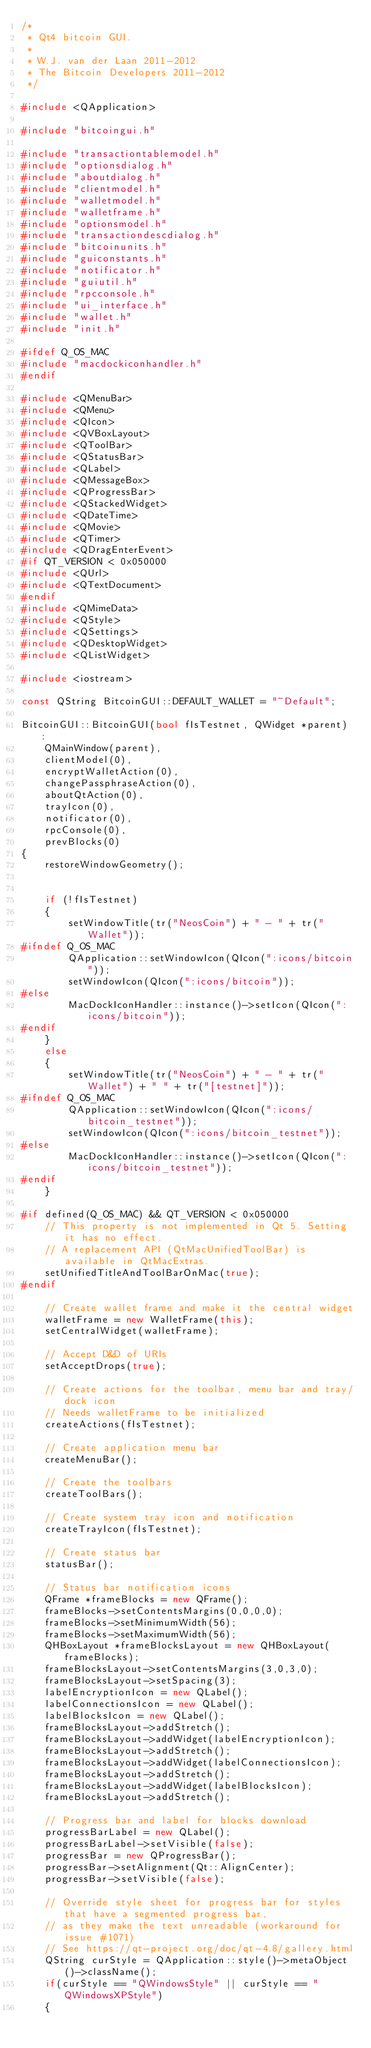<code> <loc_0><loc_0><loc_500><loc_500><_C++_>/*
 * Qt4 bitcoin GUI.
 *
 * W.J. van der Laan 2011-2012
 * The Bitcoin Developers 2011-2012
 */

#include <QApplication>

#include "bitcoingui.h"

#include "transactiontablemodel.h"
#include "optionsdialog.h"
#include "aboutdialog.h"
#include "clientmodel.h"
#include "walletmodel.h"
#include "walletframe.h"
#include "optionsmodel.h"
#include "transactiondescdialog.h"
#include "bitcoinunits.h"
#include "guiconstants.h"
#include "notificator.h"
#include "guiutil.h"
#include "rpcconsole.h"
#include "ui_interface.h"
#include "wallet.h"
#include "init.h"

#ifdef Q_OS_MAC
#include "macdockiconhandler.h"
#endif

#include <QMenuBar>
#include <QMenu>
#include <QIcon>
#include <QVBoxLayout>
#include <QToolBar>
#include <QStatusBar>
#include <QLabel>
#include <QMessageBox>
#include <QProgressBar>
#include <QStackedWidget>
#include <QDateTime>
#include <QMovie>
#include <QTimer>
#include <QDragEnterEvent>
#if QT_VERSION < 0x050000
#include <QUrl>
#include <QTextDocument>
#endif
#include <QMimeData>
#include <QStyle>
#include <QSettings>
#include <QDesktopWidget>
#include <QListWidget>

#include <iostream>

const QString BitcoinGUI::DEFAULT_WALLET = "~Default";

BitcoinGUI::BitcoinGUI(bool fIsTestnet, QWidget *parent) :
    QMainWindow(parent),
    clientModel(0),
    encryptWalletAction(0),
    changePassphraseAction(0),
    aboutQtAction(0),
    trayIcon(0),
    notificator(0),
    rpcConsole(0),
    prevBlocks(0)
{
    restoreWindowGeometry();


    if (!fIsTestnet)
    {
        setWindowTitle(tr("NeosCoin") + " - " + tr("Wallet"));
#ifndef Q_OS_MAC
        QApplication::setWindowIcon(QIcon(":icons/bitcoin"));
        setWindowIcon(QIcon(":icons/bitcoin"));
#else
        MacDockIconHandler::instance()->setIcon(QIcon(":icons/bitcoin"));
#endif
    }
    else
    {
        setWindowTitle(tr("NeosCoin") + " - " + tr("Wallet") + " " + tr("[testnet]"));
#ifndef Q_OS_MAC
        QApplication::setWindowIcon(QIcon(":icons/bitcoin_testnet"));
        setWindowIcon(QIcon(":icons/bitcoin_testnet"));
#else
        MacDockIconHandler::instance()->setIcon(QIcon(":icons/bitcoin_testnet"));
#endif
    }

#if defined(Q_OS_MAC) && QT_VERSION < 0x050000
    // This property is not implemented in Qt 5. Setting it has no effect.
    // A replacement API (QtMacUnifiedToolBar) is available in QtMacExtras.
    setUnifiedTitleAndToolBarOnMac(true);
#endif

    // Create wallet frame and make it the central widget
    walletFrame = new WalletFrame(this);
    setCentralWidget(walletFrame);

    // Accept D&D of URIs
    setAcceptDrops(true);

    // Create actions for the toolbar, menu bar and tray/dock icon
    // Needs walletFrame to be initialized
    createActions(fIsTestnet);

    // Create application menu bar
    createMenuBar();

    // Create the toolbars
    createToolBars();

    // Create system tray icon and notification
    createTrayIcon(fIsTestnet);

    // Create status bar
    statusBar();

    // Status bar notification icons
    QFrame *frameBlocks = new QFrame();
    frameBlocks->setContentsMargins(0,0,0,0);
    frameBlocks->setMinimumWidth(56);
    frameBlocks->setMaximumWidth(56);
    QHBoxLayout *frameBlocksLayout = new QHBoxLayout(frameBlocks);
    frameBlocksLayout->setContentsMargins(3,0,3,0);
    frameBlocksLayout->setSpacing(3);
    labelEncryptionIcon = new QLabel();
    labelConnectionsIcon = new QLabel();
    labelBlocksIcon = new QLabel();
    frameBlocksLayout->addStretch();
    frameBlocksLayout->addWidget(labelEncryptionIcon);
    frameBlocksLayout->addStretch();
    frameBlocksLayout->addWidget(labelConnectionsIcon);
    frameBlocksLayout->addStretch();
    frameBlocksLayout->addWidget(labelBlocksIcon);
    frameBlocksLayout->addStretch();

    // Progress bar and label for blocks download
    progressBarLabel = new QLabel();
    progressBarLabel->setVisible(false);
    progressBar = new QProgressBar();
    progressBar->setAlignment(Qt::AlignCenter);
    progressBar->setVisible(false);

    // Override style sheet for progress bar for styles that have a segmented progress bar,
    // as they make the text unreadable (workaround for issue #1071)
    // See https://qt-project.org/doc/qt-4.8/gallery.html
    QString curStyle = QApplication::style()->metaObject()->className();
    if(curStyle == "QWindowsStyle" || curStyle == "QWindowsXPStyle")
    {</code> 